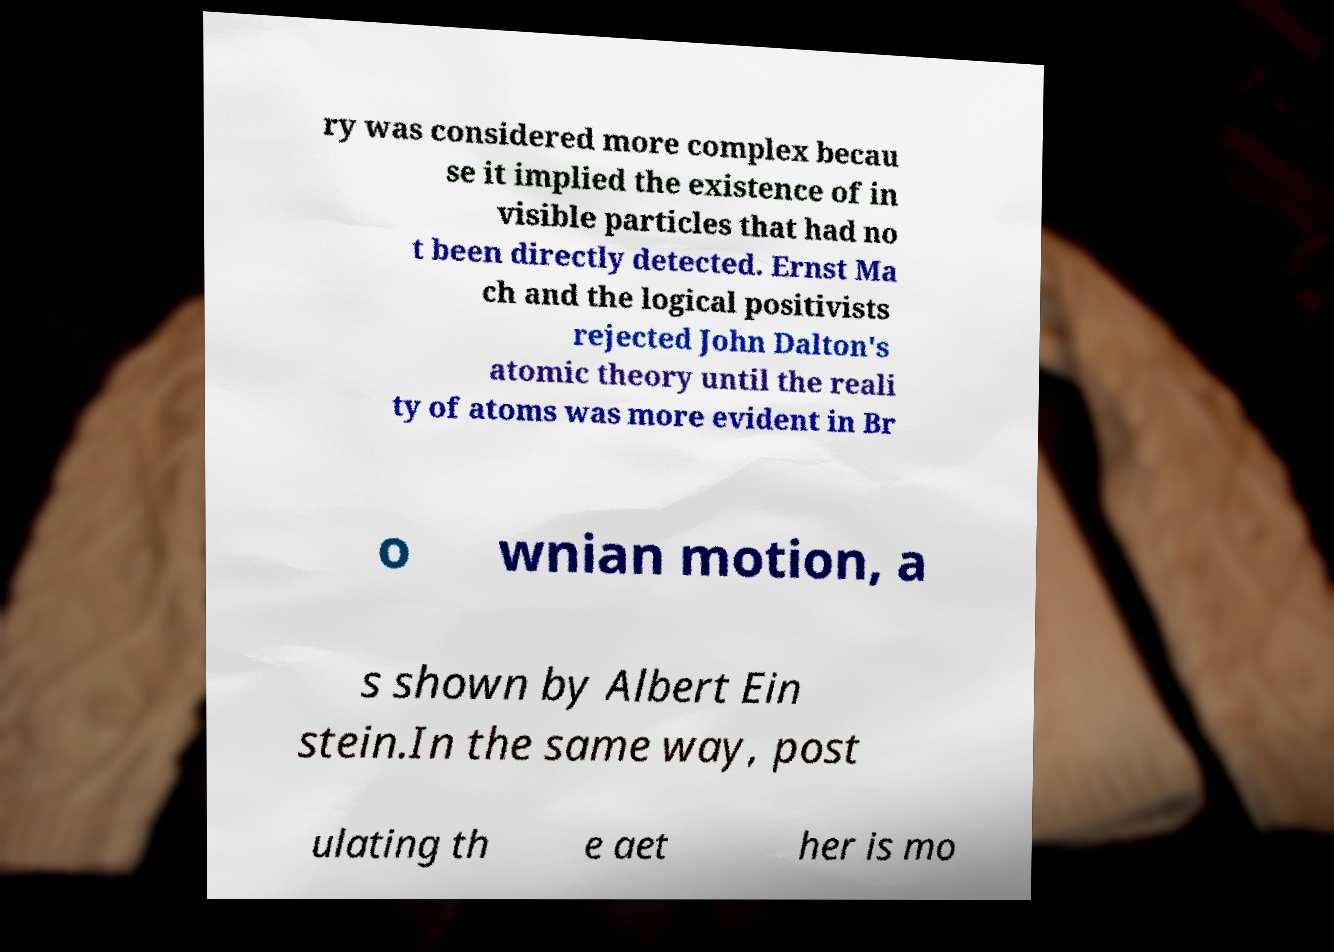I need the written content from this picture converted into text. Can you do that? ry was considered more complex becau se it implied the existence of in visible particles that had no t been directly detected. Ernst Ma ch and the logical positivists rejected John Dalton's atomic theory until the reali ty of atoms was more evident in Br o wnian motion, a s shown by Albert Ein stein.In the same way, post ulating th e aet her is mo 